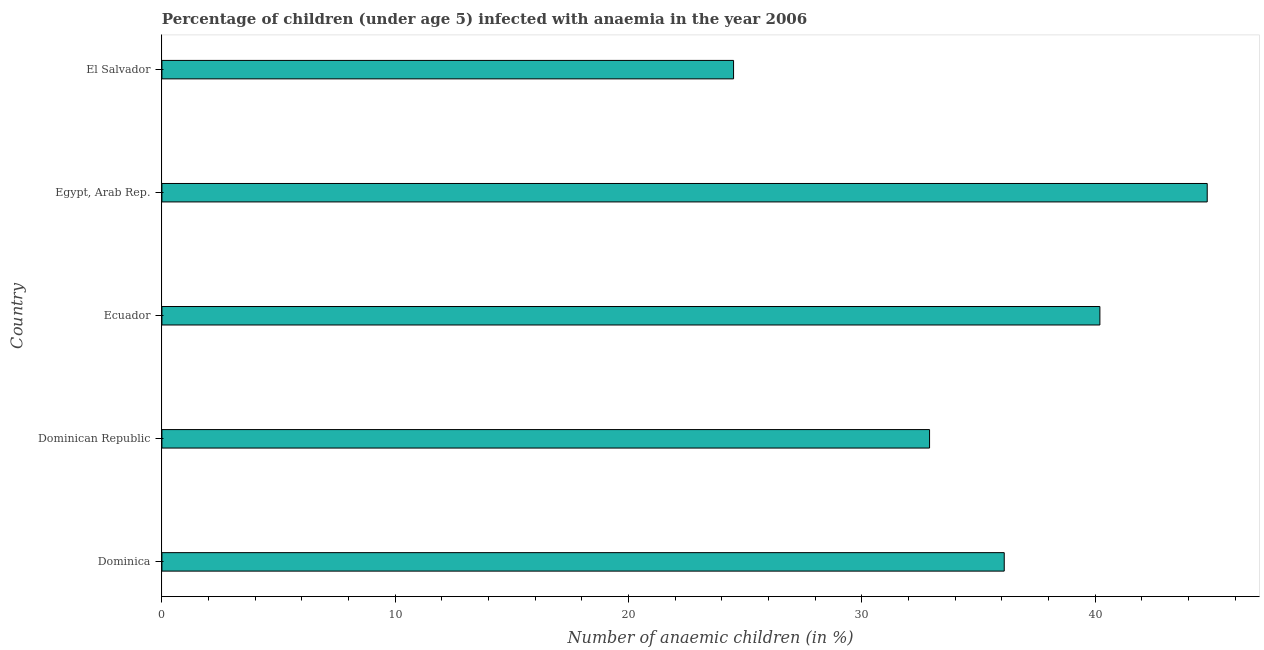What is the title of the graph?
Provide a short and direct response. Percentage of children (under age 5) infected with anaemia in the year 2006. What is the label or title of the X-axis?
Your answer should be very brief. Number of anaemic children (in %). What is the number of anaemic children in Dominica?
Provide a succinct answer. 36.1. Across all countries, what is the maximum number of anaemic children?
Your answer should be compact. 44.8. In which country was the number of anaemic children maximum?
Your answer should be compact. Egypt, Arab Rep. In which country was the number of anaemic children minimum?
Provide a short and direct response. El Salvador. What is the sum of the number of anaemic children?
Give a very brief answer. 178.5. What is the difference between the number of anaemic children in Ecuador and El Salvador?
Give a very brief answer. 15.7. What is the average number of anaemic children per country?
Provide a succinct answer. 35.7. What is the median number of anaemic children?
Your answer should be very brief. 36.1. What is the ratio of the number of anaemic children in Ecuador to that in Egypt, Arab Rep.?
Make the answer very short. 0.9. Is the number of anaemic children in Dominica less than that in El Salvador?
Ensure brevity in your answer.  No. Is the difference between the number of anaemic children in Ecuador and Egypt, Arab Rep. greater than the difference between any two countries?
Offer a very short reply. No. Is the sum of the number of anaemic children in Dominican Republic and Ecuador greater than the maximum number of anaemic children across all countries?
Make the answer very short. Yes. What is the difference between the highest and the lowest number of anaemic children?
Keep it short and to the point. 20.3. Are all the bars in the graph horizontal?
Provide a succinct answer. Yes. Are the values on the major ticks of X-axis written in scientific E-notation?
Keep it short and to the point. No. What is the Number of anaemic children (in %) in Dominica?
Ensure brevity in your answer.  36.1. What is the Number of anaemic children (in %) of Dominican Republic?
Make the answer very short. 32.9. What is the Number of anaemic children (in %) of Ecuador?
Offer a very short reply. 40.2. What is the Number of anaemic children (in %) of Egypt, Arab Rep.?
Offer a very short reply. 44.8. What is the Number of anaemic children (in %) in El Salvador?
Keep it short and to the point. 24.5. What is the difference between the Number of anaemic children (in %) in Dominican Republic and Ecuador?
Provide a succinct answer. -7.3. What is the difference between the Number of anaemic children (in %) in Ecuador and Egypt, Arab Rep.?
Provide a short and direct response. -4.6. What is the difference between the Number of anaemic children (in %) in Ecuador and El Salvador?
Offer a very short reply. 15.7. What is the difference between the Number of anaemic children (in %) in Egypt, Arab Rep. and El Salvador?
Your answer should be very brief. 20.3. What is the ratio of the Number of anaemic children (in %) in Dominica to that in Dominican Republic?
Your answer should be very brief. 1.1. What is the ratio of the Number of anaemic children (in %) in Dominica to that in Ecuador?
Give a very brief answer. 0.9. What is the ratio of the Number of anaemic children (in %) in Dominica to that in Egypt, Arab Rep.?
Make the answer very short. 0.81. What is the ratio of the Number of anaemic children (in %) in Dominica to that in El Salvador?
Your response must be concise. 1.47. What is the ratio of the Number of anaemic children (in %) in Dominican Republic to that in Ecuador?
Ensure brevity in your answer.  0.82. What is the ratio of the Number of anaemic children (in %) in Dominican Republic to that in Egypt, Arab Rep.?
Provide a short and direct response. 0.73. What is the ratio of the Number of anaemic children (in %) in Dominican Republic to that in El Salvador?
Your answer should be very brief. 1.34. What is the ratio of the Number of anaemic children (in %) in Ecuador to that in Egypt, Arab Rep.?
Provide a succinct answer. 0.9. What is the ratio of the Number of anaemic children (in %) in Ecuador to that in El Salvador?
Keep it short and to the point. 1.64. What is the ratio of the Number of anaemic children (in %) in Egypt, Arab Rep. to that in El Salvador?
Your answer should be very brief. 1.83. 